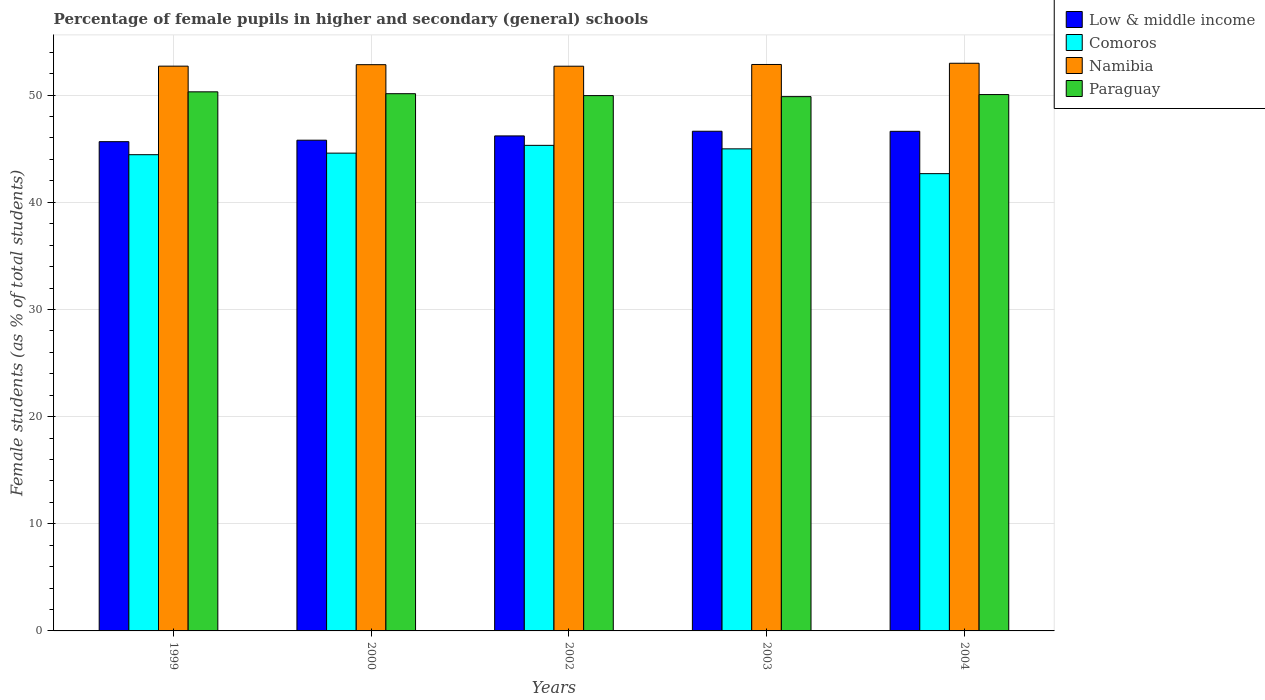How many groups of bars are there?
Provide a short and direct response. 5. How many bars are there on the 2nd tick from the right?
Offer a terse response. 4. What is the label of the 2nd group of bars from the left?
Your answer should be compact. 2000. What is the percentage of female pupils in higher and secondary schools in Paraguay in 2003?
Your response must be concise. 49.86. Across all years, what is the maximum percentage of female pupils in higher and secondary schools in Namibia?
Keep it short and to the point. 52.97. Across all years, what is the minimum percentage of female pupils in higher and secondary schools in Namibia?
Make the answer very short. 52.7. In which year was the percentage of female pupils in higher and secondary schools in Low & middle income maximum?
Provide a short and direct response. 2003. In which year was the percentage of female pupils in higher and secondary schools in Comoros minimum?
Offer a terse response. 2004. What is the total percentage of female pupils in higher and secondary schools in Comoros in the graph?
Give a very brief answer. 222. What is the difference between the percentage of female pupils in higher and secondary schools in Low & middle income in 1999 and that in 2004?
Offer a very short reply. -0.96. What is the difference between the percentage of female pupils in higher and secondary schools in Paraguay in 2000 and the percentage of female pupils in higher and secondary schools in Low & middle income in 2004?
Offer a terse response. 3.51. What is the average percentage of female pupils in higher and secondary schools in Comoros per year?
Give a very brief answer. 44.4. In the year 2002, what is the difference between the percentage of female pupils in higher and secondary schools in Low & middle income and percentage of female pupils in higher and secondary schools in Comoros?
Ensure brevity in your answer.  0.88. In how many years, is the percentage of female pupils in higher and secondary schools in Comoros greater than 6 %?
Your answer should be very brief. 5. What is the ratio of the percentage of female pupils in higher and secondary schools in Namibia in 2000 to that in 2004?
Your answer should be very brief. 1. Is the percentage of female pupils in higher and secondary schools in Paraguay in 2002 less than that in 2003?
Your response must be concise. No. Is the difference between the percentage of female pupils in higher and secondary schools in Low & middle income in 1999 and 2004 greater than the difference between the percentage of female pupils in higher and secondary schools in Comoros in 1999 and 2004?
Your answer should be very brief. No. What is the difference between the highest and the second highest percentage of female pupils in higher and secondary schools in Namibia?
Make the answer very short. 0.11. What is the difference between the highest and the lowest percentage of female pupils in higher and secondary schools in Paraguay?
Keep it short and to the point. 0.45. In how many years, is the percentage of female pupils in higher and secondary schools in Namibia greater than the average percentage of female pupils in higher and secondary schools in Namibia taken over all years?
Provide a short and direct response. 3. What does the 4th bar from the left in 2004 represents?
Give a very brief answer. Paraguay. Is it the case that in every year, the sum of the percentage of female pupils in higher and secondary schools in Namibia and percentage of female pupils in higher and secondary schools in Low & middle income is greater than the percentage of female pupils in higher and secondary schools in Comoros?
Ensure brevity in your answer.  Yes. How many bars are there?
Your answer should be compact. 20. Are all the bars in the graph horizontal?
Offer a terse response. No. How many years are there in the graph?
Provide a succinct answer. 5. Are the values on the major ticks of Y-axis written in scientific E-notation?
Offer a terse response. No. Where does the legend appear in the graph?
Keep it short and to the point. Top right. What is the title of the graph?
Keep it short and to the point. Percentage of female pupils in higher and secondary (general) schools. Does "Ireland" appear as one of the legend labels in the graph?
Ensure brevity in your answer.  No. What is the label or title of the X-axis?
Ensure brevity in your answer.  Years. What is the label or title of the Y-axis?
Offer a very short reply. Female students (as % of total students). What is the Female students (as % of total students) of Low & middle income in 1999?
Offer a terse response. 45.66. What is the Female students (as % of total students) of Comoros in 1999?
Your response must be concise. 44.44. What is the Female students (as % of total students) of Namibia in 1999?
Your response must be concise. 52.71. What is the Female students (as % of total students) in Paraguay in 1999?
Ensure brevity in your answer.  50.31. What is the Female students (as % of total students) of Low & middle income in 2000?
Give a very brief answer. 45.79. What is the Female students (as % of total students) in Comoros in 2000?
Provide a short and direct response. 44.59. What is the Female students (as % of total students) of Namibia in 2000?
Your response must be concise. 52.84. What is the Female students (as % of total students) of Paraguay in 2000?
Provide a succinct answer. 50.13. What is the Female students (as % of total students) in Low & middle income in 2002?
Ensure brevity in your answer.  46.19. What is the Female students (as % of total students) of Comoros in 2002?
Provide a succinct answer. 45.31. What is the Female students (as % of total students) in Namibia in 2002?
Your answer should be compact. 52.7. What is the Female students (as % of total students) of Paraguay in 2002?
Keep it short and to the point. 49.96. What is the Female students (as % of total students) of Low & middle income in 2003?
Give a very brief answer. 46.63. What is the Female students (as % of total students) in Comoros in 2003?
Make the answer very short. 44.99. What is the Female students (as % of total students) of Namibia in 2003?
Your answer should be compact. 52.86. What is the Female students (as % of total students) in Paraguay in 2003?
Give a very brief answer. 49.86. What is the Female students (as % of total students) in Low & middle income in 2004?
Your answer should be compact. 46.62. What is the Female students (as % of total students) of Comoros in 2004?
Offer a very short reply. 42.67. What is the Female students (as % of total students) in Namibia in 2004?
Your answer should be compact. 52.97. What is the Female students (as % of total students) in Paraguay in 2004?
Your answer should be compact. 50.05. Across all years, what is the maximum Female students (as % of total students) of Low & middle income?
Give a very brief answer. 46.63. Across all years, what is the maximum Female students (as % of total students) in Comoros?
Offer a terse response. 45.31. Across all years, what is the maximum Female students (as % of total students) in Namibia?
Your answer should be compact. 52.97. Across all years, what is the maximum Female students (as % of total students) of Paraguay?
Your response must be concise. 50.31. Across all years, what is the minimum Female students (as % of total students) of Low & middle income?
Give a very brief answer. 45.66. Across all years, what is the minimum Female students (as % of total students) in Comoros?
Make the answer very short. 42.67. Across all years, what is the minimum Female students (as % of total students) in Namibia?
Offer a very short reply. 52.7. Across all years, what is the minimum Female students (as % of total students) in Paraguay?
Your response must be concise. 49.86. What is the total Female students (as % of total students) in Low & middle income in the graph?
Offer a terse response. 230.9. What is the total Female students (as % of total students) of Comoros in the graph?
Give a very brief answer. 222. What is the total Female students (as % of total students) of Namibia in the graph?
Offer a terse response. 264.08. What is the total Female students (as % of total students) in Paraguay in the graph?
Offer a very short reply. 250.31. What is the difference between the Female students (as % of total students) in Low & middle income in 1999 and that in 2000?
Keep it short and to the point. -0.14. What is the difference between the Female students (as % of total students) in Comoros in 1999 and that in 2000?
Make the answer very short. -0.15. What is the difference between the Female students (as % of total students) of Namibia in 1999 and that in 2000?
Your answer should be compact. -0.14. What is the difference between the Female students (as % of total students) in Paraguay in 1999 and that in 2000?
Offer a very short reply. 0.17. What is the difference between the Female students (as % of total students) of Low & middle income in 1999 and that in 2002?
Ensure brevity in your answer.  -0.54. What is the difference between the Female students (as % of total students) in Comoros in 1999 and that in 2002?
Provide a succinct answer. -0.87. What is the difference between the Female students (as % of total students) of Namibia in 1999 and that in 2002?
Make the answer very short. 0.01. What is the difference between the Female students (as % of total students) of Paraguay in 1999 and that in 2002?
Ensure brevity in your answer.  0.35. What is the difference between the Female students (as % of total students) in Low & middle income in 1999 and that in 2003?
Your response must be concise. -0.97. What is the difference between the Female students (as % of total students) in Comoros in 1999 and that in 2003?
Ensure brevity in your answer.  -0.54. What is the difference between the Female students (as % of total students) of Namibia in 1999 and that in 2003?
Your answer should be compact. -0.16. What is the difference between the Female students (as % of total students) of Paraguay in 1999 and that in 2003?
Make the answer very short. 0.45. What is the difference between the Female students (as % of total students) of Low & middle income in 1999 and that in 2004?
Keep it short and to the point. -0.96. What is the difference between the Female students (as % of total students) of Comoros in 1999 and that in 2004?
Make the answer very short. 1.77. What is the difference between the Female students (as % of total students) of Namibia in 1999 and that in 2004?
Offer a very short reply. -0.27. What is the difference between the Female students (as % of total students) in Paraguay in 1999 and that in 2004?
Your answer should be compact. 0.26. What is the difference between the Female students (as % of total students) in Low & middle income in 2000 and that in 2002?
Make the answer very short. -0.4. What is the difference between the Female students (as % of total students) in Comoros in 2000 and that in 2002?
Make the answer very short. -0.73. What is the difference between the Female students (as % of total students) in Namibia in 2000 and that in 2002?
Your answer should be compact. 0.14. What is the difference between the Female students (as % of total students) in Paraguay in 2000 and that in 2002?
Your answer should be very brief. 0.18. What is the difference between the Female students (as % of total students) in Low & middle income in 2000 and that in 2003?
Ensure brevity in your answer.  -0.84. What is the difference between the Female students (as % of total students) in Comoros in 2000 and that in 2003?
Offer a very short reply. -0.4. What is the difference between the Female students (as % of total students) in Namibia in 2000 and that in 2003?
Give a very brief answer. -0.02. What is the difference between the Female students (as % of total students) of Paraguay in 2000 and that in 2003?
Keep it short and to the point. 0.27. What is the difference between the Female students (as % of total students) of Low & middle income in 2000 and that in 2004?
Make the answer very short. -0.83. What is the difference between the Female students (as % of total students) of Comoros in 2000 and that in 2004?
Give a very brief answer. 1.91. What is the difference between the Female students (as % of total students) of Namibia in 2000 and that in 2004?
Your answer should be very brief. -0.13. What is the difference between the Female students (as % of total students) in Paraguay in 2000 and that in 2004?
Ensure brevity in your answer.  0.08. What is the difference between the Female students (as % of total students) of Low & middle income in 2002 and that in 2003?
Offer a terse response. -0.44. What is the difference between the Female students (as % of total students) in Comoros in 2002 and that in 2003?
Ensure brevity in your answer.  0.33. What is the difference between the Female students (as % of total students) of Namibia in 2002 and that in 2003?
Your answer should be compact. -0.16. What is the difference between the Female students (as % of total students) in Paraguay in 2002 and that in 2003?
Offer a very short reply. 0.1. What is the difference between the Female students (as % of total students) in Low & middle income in 2002 and that in 2004?
Provide a short and direct response. -0.43. What is the difference between the Female students (as % of total students) in Comoros in 2002 and that in 2004?
Provide a succinct answer. 2.64. What is the difference between the Female students (as % of total students) in Namibia in 2002 and that in 2004?
Your response must be concise. -0.28. What is the difference between the Female students (as % of total students) of Paraguay in 2002 and that in 2004?
Give a very brief answer. -0.1. What is the difference between the Female students (as % of total students) of Low & middle income in 2003 and that in 2004?
Your answer should be very brief. 0.01. What is the difference between the Female students (as % of total students) of Comoros in 2003 and that in 2004?
Provide a short and direct response. 2.31. What is the difference between the Female students (as % of total students) of Namibia in 2003 and that in 2004?
Make the answer very short. -0.11. What is the difference between the Female students (as % of total students) in Paraguay in 2003 and that in 2004?
Offer a terse response. -0.19. What is the difference between the Female students (as % of total students) in Low & middle income in 1999 and the Female students (as % of total students) in Comoros in 2000?
Give a very brief answer. 1.07. What is the difference between the Female students (as % of total students) of Low & middle income in 1999 and the Female students (as % of total students) of Namibia in 2000?
Give a very brief answer. -7.18. What is the difference between the Female students (as % of total students) in Low & middle income in 1999 and the Female students (as % of total students) in Paraguay in 2000?
Offer a terse response. -4.48. What is the difference between the Female students (as % of total students) in Comoros in 1999 and the Female students (as % of total students) in Namibia in 2000?
Provide a short and direct response. -8.4. What is the difference between the Female students (as % of total students) in Comoros in 1999 and the Female students (as % of total students) in Paraguay in 2000?
Give a very brief answer. -5.69. What is the difference between the Female students (as % of total students) of Namibia in 1999 and the Female students (as % of total students) of Paraguay in 2000?
Your response must be concise. 2.57. What is the difference between the Female students (as % of total students) in Low & middle income in 1999 and the Female students (as % of total students) in Comoros in 2002?
Ensure brevity in your answer.  0.34. What is the difference between the Female students (as % of total students) in Low & middle income in 1999 and the Female students (as % of total students) in Namibia in 2002?
Ensure brevity in your answer.  -7.04. What is the difference between the Female students (as % of total students) in Low & middle income in 1999 and the Female students (as % of total students) in Paraguay in 2002?
Provide a short and direct response. -4.3. What is the difference between the Female students (as % of total students) in Comoros in 1999 and the Female students (as % of total students) in Namibia in 2002?
Make the answer very short. -8.26. What is the difference between the Female students (as % of total students) in Comoros in 1999 and the Female students (as % of total students) in Paraguay in 2002?
Offer a very short reply. -5.51. What is the difference between the Female students (as % of total students) in Namibia in 1999 and the Female students (as % of total students) in Paraguay in 2002?
Offer a terse response. 2.75. What is the difference between the Female students (as % of total students) in Low & middle income in 1999 and the Female students (as % of total students) in Comoros in 2003?
Your answer should be very brief. 0.67. What is the difference between the Female students (as % of total students) of Low & middle income in 1999 and the Female students (as % of total students) of Namibia in 2003?
Keep it short and to the point. -7.2. What is the difference between the Female students (as % of total students) of Low & middle income in 1999 and the Female students (as % of total students) of Paraguay in 2003?
Give a very brief answer. -4.2. What is the difference between the Female students (as % of total students) of Comoros in 1999 and the Female students (as % of total students) of Namibia in 2003?
Your response must be concise. -8.42. What is the difference between the Female students (as % of total students) of Comoros in 1999 and the Female students (as % of total students) of Paraguay in 2003?
Your response must be concise. -5.42. What is the difference between the Female students (as % of total students) of Namibia in 1999 and the Female students (as % of total students) of Paraguay in 2003?
Your response must be concise. 2.85. What is the difference between the Female students (as % of total students) of Low & middle income in 1999 and the Female students (as % of total students) of Comoros in 2004?
Your response must be concise. 2.98. What is the difference between the Female students (as % of total students) in Low & middle income in 1999 and the Female students (as % of total students) in Namibia in 2004?
Keep it short and to the point. -7.32. What is the difference between the Female students (as % of total students) of Low & middle income in 1999 and the Female students (as % of total students) of Paraguay in 2004?
Keep it short and to the point. -4.39. What is the difference between the Female students (as % of total students) in Comoros in 1999 and the Female students (as % of total students) in Namibia in 2004?
Give a very brief answer. -8.53. What is the difference between the Female students (as % of total students) in Comoros in 1999 and the Female students (as % of total students) in Paraguay in 2004?
Ensure brevity in your answer.  -5.61. What is the difference between the Female students (as % of total students) in Namibia in 1999 and the Female students (as % of total students) in Paraguay in 2004?
Ensure brevity in your answer.  2.65. What is the difference between the Female students (as % of total students) in Low & middle income in 2000 and the Female students (as % of total students) in Comoros in 2002?
Provide a short and direct response. 0.48. What is the difference between the Female students (as % of total students) in Low & middle income in 2000 and the Female students (as % of total students) in Namibia in 2002?
Your response must be concise. -6.9. What is the difference between the Female students (as % of total students) of Low & middle income in 2000 and the Female students (as % of total students) of Paraguay in 2002?
Provide a short and direct response. -4.16. What is the difference between the Female students (as % of total students) of Comoros in 2000 and the Female students (as % of total students) of Namibia in 2002?
Offer a terse response. -8.11. What is the difference between the Female students (as % of total students) of Comoros in 2000 and the Female students (as % of total students) of Paraguay in 2002?
Keep it short and to the point. -5.37. What is the difference between the Female students (as % of total students) of Namibia in 2000 and the Female students (as % of total students) of Paraguay in 2002?
Provide a succinct answer. 2.89. What is the difference between the Female students (as % of total students) of Low & middle income in 2000 and the Female students (as % of total students) of Comoros in 2003?
Keep it short and to the point. 0.81. What is the difference between the Female students (as % of total students) of Low & middle income in 2000 and the Female students (as % of total students) of Namibia in 2003?
Your answer should be very brief. -7.07. What is the difference between the Female students (as % of total students) in Low & middle income in 2000 and the Female students (as % of total students) in Paraguay in 2003?
Make the answer very short. -4.07. What is the difference between the Female students (as % of total students) in Comoros in 2000 and the Female students (as % of total students) in Namibia in 2003?
Offer a terse response. -8.27. What is the difference between the Female students (as % of total students) of Comoros in 2000 and the Female students (as % of total students) of Paraguay in 2003?
Ensure brevity in your answer.  -5.27. What is the difference between the Female students (as % of total students) in Namibia in 2000 and the Female students (as % of total students) in Paraguay in 2003?
Your answer should be very brief. 2.98. What is the difference between the Female students (as % of total students) of Low & middle income in 2000 and the Female students (as % of total students) of Comoros in 2004?
Give a very brief answer. 3.12. What is the difference between the Female students (as % of total students) in Low & middle income in 2000 and the Female students (as % of total students) in Namibia in 2004?
Ensure brevity in your answer.  -7.18. What is the difference between the Female students (as % of total students) in Low & middle income in 2000 and the Female students (as % of total students) in Paraguay in 2004?
Make the answer very short. -4.26. What is the difference between the Female students (as % of total students) of Comoros in 2000 and the Female students (as % of total students) of Namibia in 2004?
Offer a very short reply. -8.39. What is the difference between the Female students (as % of total students) of Comoros in 2000 and the Female students (as % of total students) of Paraguay in 2004?
Keep it short and to the point. -5.47. What is the difference between the Female students (as % of total students) in Namibia in 2000 and the Female students (as % of total students) in Paraguay in 2004?
Make the answer very short. 2.79. What is the difference between the Female students (as % of total students) of Low & middle income in 2002 and the Female students (as % of total students) of Comoros in 2003?
Your answer should be compact. 1.21. What is the difference between the Female students (as % of total students) of Low & middle income in 2002 and the Female students (as % of total students) of Namibia in 2003?
Ensure brevity in your answer.  -6.67. What is the difference between the Female students (as % of total students) in Low & middle income in 2002 and the Female students (as % of total students) in Paraguay in 2003?
Give a very brief answer. -3.67. What is the difference between the Female students (as % of total students) of Comoros in 2002 and the Female students (as % of total students) of Namibia in 2003?
Ensure brevity in your answer.  -7.55. What is the difference between the Female students (as % of total students) of Comoros in 2002 and the Female students (as % of total students) of Paraguay in 2003?
Provide a succinct answer. -4.55. What is the difference between the Female students (as % of total students) in Namibia in 2002 and the Female students (as % of total students) in Paraguay in 2003?
Give a very brief answer. 2.84. What is the difference between the Female students (as % of total students) in Low & middle income in 2002 and the Female students (as % of total students) in Comoros in 2004?
Offer a very short reply. 3.52. What is the difference between the Female students (as % of total students) of Low & middle income in 2002 and the Female students (as % of total students) of Namibia in 2004?
Your answer should be very brief. -6.78. What is the difference between the Female students (as % of total students) of Low & middle income in 2002 and the Female students (as % of total students) of Paraguay in 2004?
Offer a terse response. -3.86. What is the difference between the Female students (as % of total students) of Comoros in 2002 and the Female students (as % of total students) of Namibia in 2004?
Your answer should be compact. -7.66. What is the difference between the Female students (as % of total students) of Comoros in 2002 and the Female students (as % of total students) of Paraguay in 2004?
Keep it short and to the point. -4.74. What is the difference between the Female students (as % of total students) in Namibia in 2002 and the Female students (as % of total students) in Paraguay in 2004?
Offer a very short reply. 2.65. What is the difference between the Female students (as % of total students) of Low & middle income in 2003 and the Female students (as % of total students) of Comoros in 2004?
Offer a very short reply. 3.96. What is the difference between the Female students (as % of total students) in Low & middle income in 2003 and the Female students (as % of total students) in Namibia in 2004?
Make the answer very short. -6.34. What is the difference between the Female students (as % of total students) of Low & middle income in 2003 and the Female students (as % of total students) of Paraguay in 2004?
Offer a terse response. -3.42. What is the difference between the Female students (as % of total students) in Comoros in 2003 and the Female students (as % of total students) in Namibia in 2004?
Provide a succinct answer. -7.99. What is the difference between the Female students (as % of total students) in Comoros in 2003 and the Female students (as % of total students) in Paraguay in 2004?
Make the answer very short. -5.07. What is the difference between the Female students (as % of total students) of Namibia in 2003 and the Female students (as % of total students) of Paraguay in 2004?
Ensure brevity in your answer.  2.81. What is the average Female students (as % of total students) in Low & middle income per year?
Give a very brief answer. 46.18. What is the average Female students (as % of total students) of Comoros per year?
Make the answer very short. 44.4. What is the average Female students (as % of total students) in Namibia per year?
Provide a succinct answer. 52.82. What is the average Female students (as % of total students) in Paraguay per year?
Your answer should be compact. 50.06. In the year 1999, what is the difference between the Female students (as % of total students) in Low & middle income and Female students (as % of total students) in Comoros?
Give a very brief answer. 1.22. In the year 1999, what is the difference between the Female students (as % of total students) of Low & middle income and Female students (as % of total students) of Namibia?
Make the answer very short. -7.05. In the year 1999, what is the difference between the Female students (as % of total students) of Low & middle income and Female students (as % of total students) of Paraguay?
Provide a succinct answer. -4.65. In the year 1999, what is the difference between the Female students (as % of total students) in Comoros and Female students (as % of total students) in Namibia?
Ensure brevity in your answer.  -8.26. In the year 1999, what is the difference between the Female students (as % of total students) in Comoros and Female students (as % of total students) in Paraguay?
Make the answer very short. -5.87. In the year 1999, what is the difference between the Female students (as % of total students) of Namibia and Female students (as % of total students) of Paraguay?
Provide a short and direct response. 2.4. In the year 2000, what is the difference between the Female students (as % of total students) of Low & middle income and Female students (as % of total students) of Comoros?
Your answer should be very brief. 1.21. In the year 2000, what is the difference between the Female students (as % of total students) in Low & middle income and Female students (as % of total students) in Namibia?
Give a very brief answer. -7.05. In the year 2000, what is the difference between the Female students (as % of total students) of Low & middle income and Female students (as % of total students) of Paraguay?
Your answer should be compact. -4.34. In the year 2000, what is the difference between the Female students (as % of total students) of Comoros and Female students (as % of total students) of Namibia?
Your answer should be compact. -8.26. In the year 2000, what is the difference between the Female students (as % of total students) in Comoros and Female students (as % of total students) in Paraguay?
Keep it short and to the point. -5.55. In the year 2000, what is the difference between the Female students (as % of total students) in Namibia and Female students (as % of total students) in Paraguay?
Your answer should be compact. 2.71. In the year 2002, what is the difference between the Female students (as % of total students) in Low & middle income and Female students (as % of total students) in Comoros?
Give a very brief answer. 0.88. In the year 2002, what is the difference between the Female students (as % of total students) of Low & middle income and Female students (as % of total students) of Namibia?
Ensure brevity in your answer.  -6.5. In the year 2002, what is the difference between the Female students (as % of total students) of Low & middle income and Female students (as % of total students) of Paraguay?
Your answer should be compact. -3.76. In the year 2002, what is the difference between the Female students (as % of total students) of Comoros and Female students (as % of total students) of Namibia?
Keep it short and to the point. -7.39. In the year 2002, what is the difference between the Female students (as % of total students) of Comoros and Female students (as % of total students) of Paraguay?
Provide a succinct answer. -4.64. In the year 2002, what is the difference between the Female students (as % of total students) in Namibia and Female students (as % of total students) in Paraguay?
Provide a short and direct response. 2.74. In the year 2003, what is the difference between the Female students (as % of total students) of Low & middle income and Female students (as % of total students) of Comoros?
Provide a short and direct response. 1.64. In the year 2003, what is the difference between the Female students (as % of total students) in Low & middle income and Female students (as % of total students) in Namibia?
Provide a succinct answer. -6.23. In the year 2003, what is the difference between the Female students (as % of total students) of Low & middle income and Female students (as % of total students) of Paraguay?
Give a very brief answer. -3.23. In the year 2003, what is the difference between the Female students (as % of total students) of Comoros and Female students (as % of total students) of Namibia?
Your answer should be very brief. -7.87. In the year 2003, what is the difference between the Female students (as % of total students) in Comoros and Female students (as % of total students) in Paraguay?
Provide a short and direct response. -4.87. In the year 2003, what is the difference between the Female students (as % of total students) of Namibia and Female students (as % of total students) of Paraguay?
Provide a succinct answer. 3. In the year 2004, what is the difference between the Female students (as % of total students) in Low & middle income and Female students (as % of total students) in Comoros?
Give a very brief answer. 3.95. In the year 2004, what is the difference between the Female students (as % of total students) in Low & middle income and Female students (as % of total students) in Namibia?
Provide a short and direct response. -6.35. In the year 2004, what is the difference between the Female students (as % of total students) of Low & middle income and Female students (as % of total students) of Paraguay?
Ensure brevity in your answer.  -3.43. In the year 2004, what is the difference between the Female students (as % of total students) of Comoros and Female students (as % of total students) of Namibia?
Offer a very short reply. -10.3. In the year 2004, what is the difference between the Female students (as % of total students) in Comoros and Female students (as % of total students) in Paraguay?
Your answer should be compact. -7.38. In the year 2004, what is the difference between the Female students (as % of total students) in Namibia and Female students (as % of total students) in Paraguay?
Give a very brief answer. 2.92. What is the ratio of the Female students (as % of total students) of Low & middle income in 1999 to that in 2000?
Your answer should be very brief. 1. What is the ratio of the Female students (as % of total students) in Comoros in 1999 to that in 2000?
Give a very brief answer. 1. What is the ratio of the Female students (as % of total students) in Low & middle income in 1999 to that in 2002?
Offer a very short reply. 0.99. What is the ratio of the Female students (as % of total students) of Comoros in 1999 to that in 2002?
Offer a very short reply. 0.98. What is the ratio of the Female students (as % of total students) of Paraguay in 1999 to that in 2002?
Ensure brevity in your answer.  1.01. What is the ratio of the Female students (as % of total students) of Low & middle income in 1999 to that in 2003?
Make the answer very short. 0.98. What is the ratio of the Female students (as % of total students) in Comoros in 1999 to that in 2003?
Give a very brief answer. 0.99. What is the ratio of the Female students (as % of total students) in Low & middle income in 1999 to that in 2004?
Offer a very short reply. 0.98. What is the ratio of the Female students (as % of total students) in Comoros in 1999 to that in 2004?
Your answer should be very brief. 1.04. What is the ratio of the Female students (as % of total students) of Paraguay in 2000 to that in 2002?
Keep it short and to the point. 1. What is the ratio of the Female students (as % of total students) in Low & middle income in 2000 to that in 2003?
Keep it short and to the point. 0.98. What is the ratio of the Female students (as % of total students) of Comoros in 2000 to that in 2003?
Your answer should be compact. 0.99. What is the ratio of the Female students (as % of total students) of Low & middle income in 2000 to that in 2004?
Offer a very short reply. 0.98. What is the ratio of the Female students (as % of total students) of Comoros in 2000 to that in 2004?
Provide a short and direct response. 1.04. What is the ratio of the Female students (as % of total students) of Namibia in 2000 to that in 2004?
Your response must be concise. 1. What is the ratio of the Female students (as % of total students) in Low & middle income in 2002 to that in 2003?
Make the answer very short. 0.99. What is the ratio of the Female students (as % of total students) in Comoros in 2002 to that in 2003?
Ensure brevity in your answer.  1.01. What is the ratio of the Female students (as % of total students) of Low & middle income in 2002 to that in 2004?
Provide a succinct answer. 0.99. What is the ratio of the Female students (as % of total students) in Comoros in 2002 to that in 2004?
Your response must be concise. 1.06. What is the ratio of the Female students (as % of total students) in Namibia in 2002 to that in 2004?
Offer a terse response. 0.99. What is the ratio of the Female students (as % of total students) in Paraguay in 2002 to that in 2004?
Your response must be concise. 1. What is the ratio of the Female students (as % of total students) of Low & middle income in 2003 to that in 2004?
Your answer should be compact. 1. What is the ratio of the Female students (as % of total students) of Comoros in 2003 to that in 2004?
Your answer should be very brief. 1.05. What is the difference between the highest and the second highest Female students (as % of total students) in Low & middle income?
Offer a terse response. 0.01. What is the difference between the highest and the second highest Female students (as % of total students) in Comoros?
Your answer should be very brief. 0.33. What is the difference between the highest and the second highest Female students (as % of total students) of Namibia?
Provide a short and direct response. 0.11. What is the difference between the highest and the second highest Female students (as % of total students) in Paraguay?
Your answer should be compact. 0.17. What is the difference between the highest and the lowest Female students (as % of total students) of Low & middle income?
Provide a succinct answer. 0.97. What is the difference between the highest and the lowest Female students (as % of total students) of Comoros?
Make the answer very short. 2.64. What is the difference between the highest and the lowest Female students (as % of total students) in Namibia?
Offer a terse response. 0.28. What is the difference between the highest and the lowest Female students (as % of total students) of Paraguay?
Make the answer very short. 0.45. 